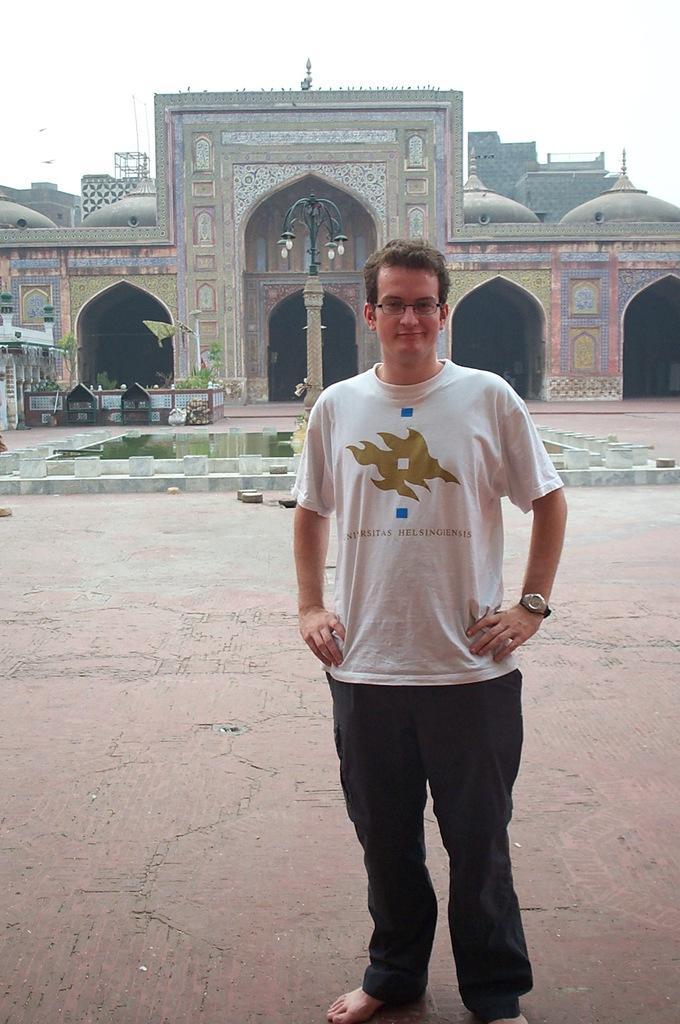Describe this image in one or two sentences. In the foreground of this picture, there is a man standing in front of a mosque. In the background, there is a fountain, mosque and the sky. 